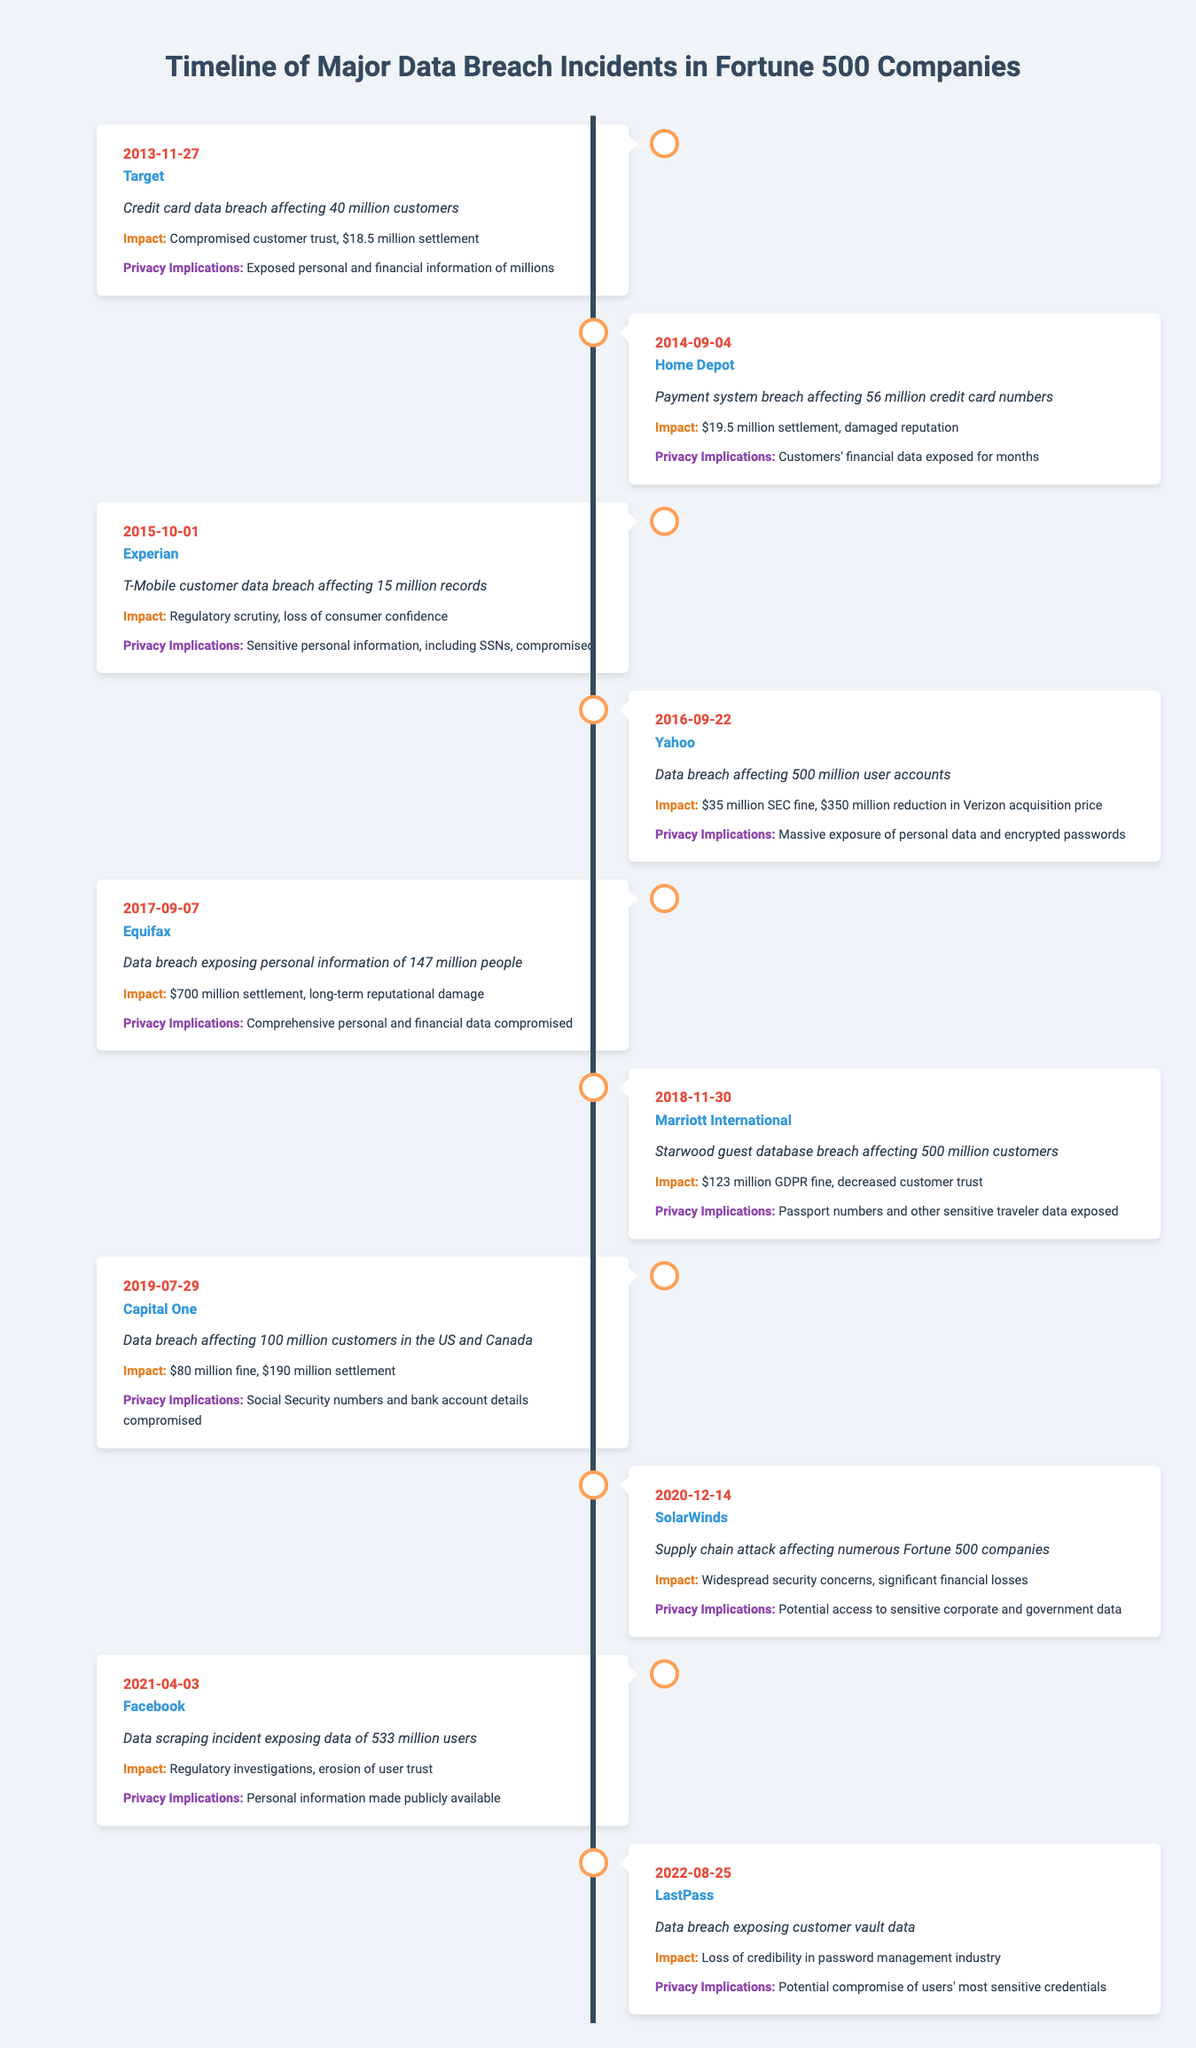What was the date of the data breach at Target? The breach at Target occurred on November 27, 2013, as listed in the timeline.
Answer: November 27, 2013 Which company experienced a data breach affecting 500 million user accounts in 2016? In 2016, Yahoo experienced a data breach affecting 500 million user accounts, as indicated in the incident description for that year.
Answer: Yahoo How many customers were affected by the Capital One data breach? The Capital One data breach affected 100 million customers in the US and Canada, which is directly stated in the incident details for that year.
Answer: 100 million Did LastPass face a data breach that affected customer vault data? Yes, LastPass experienced a data breach that exposed customer vault data, as mentioned in the incident description.
Answer: Yes What is the total amount of settlement and fines for the Equifax data breach? The Equifax data breach resulted in a $700 million settlement. Since there is no additional fine listed for Equifax in the timeline, the total amount is $700 million.
Answer: $700 million Which company had the highest settlement amount listed in the timeline, and what was the amount? Equifax had the highest settlement amount at $700 million, making it the standout case in terms of financial impact as indicated in the impact column for that incident.
Answer: Equifax; $700 million What are the privacy implications related to the Home Depot data breach? The privacy implications of the Home Depot breach involved customers' financial data being exposed for months, as noted in the relevant row regarding this specific incident.
Answer: Customers' financial data exposed for months Was there any breach that involved passport numbers being exposed? Yes, the Marriott International data breach involved the exposure of passport numbers along with other sensitive traveler data, as outlined in the appropriate entry for that incident.
Answer: Yes How many data breaches occurred in the timeline in the year 2019? The timeline indicates that there was one major data breach in 2019, which is the Capital One incident listed on July 29, 2019.
Answer: 1 Which company experienced a supply chain attack, and when did it occur? SolarWinds experienced a supply chain attack on December 14, 2020, as noted in the timeline for that date.
Answer: SolarWinds; December 14, 2020 